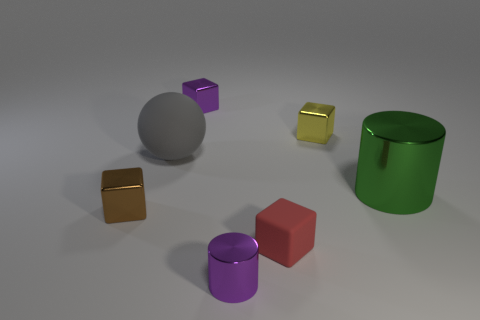Subtract all small purple blocks. How many blocks are left? 3 Add 3 purple metallic objects. How many objects exist? 10 Subtract all brown cubes. How many cubes are left? 3 Subtract 1 cylinders. How many cylinders are left? 1 Subtract all balls. How many objects are left? 6 Subtract all red cubes. Subtract all red cylinders. How many cubes are left? 3 Subtract all blue cylinders. How many brown cubes are left? 1 Add 7 purple metal cylinders. How many purple metal cylinders exist? 8 Subtract 1 red blocks. How many objects are left? 6 Subtract all purple blocks. Subtract all red matte cubes. How many objects are left? 5 